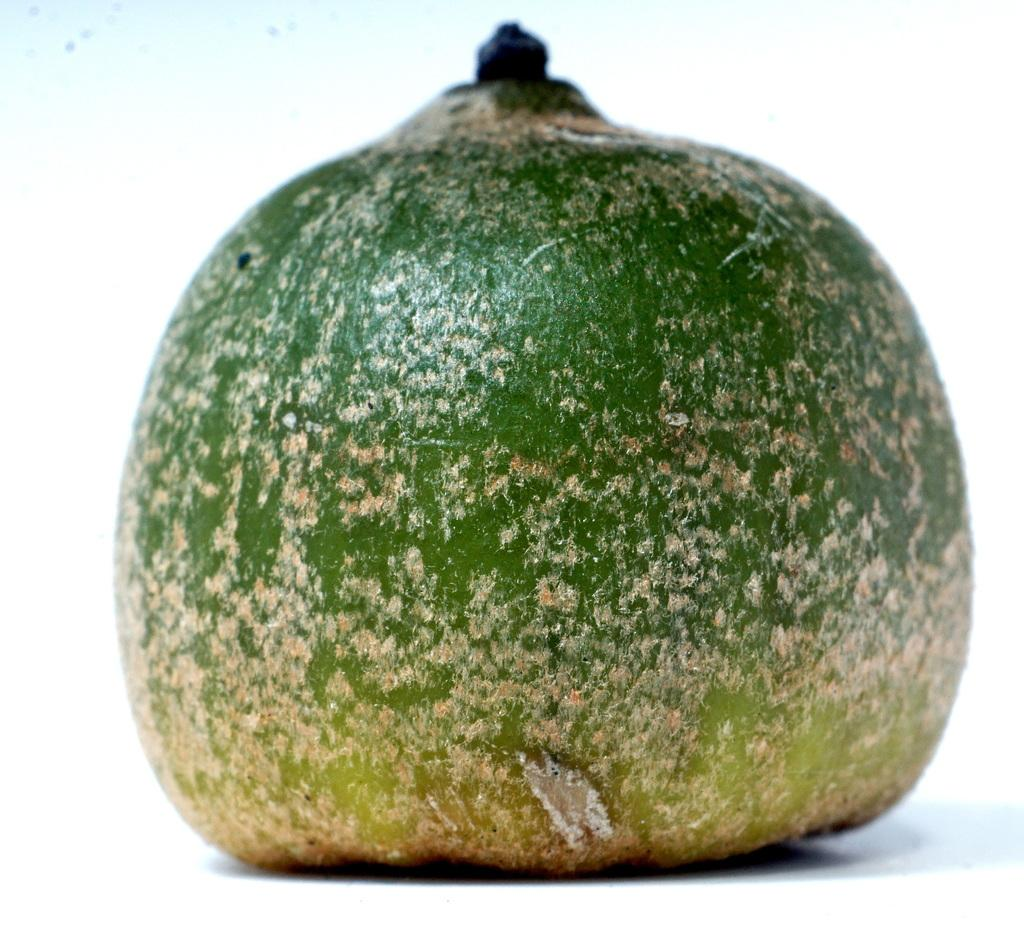What color is the fruit in the image? The fruit in the image is green. What type of comb is being used to play volleyball in the image? There is no comb or volleyball present in the image; it only features a green color fruit. 